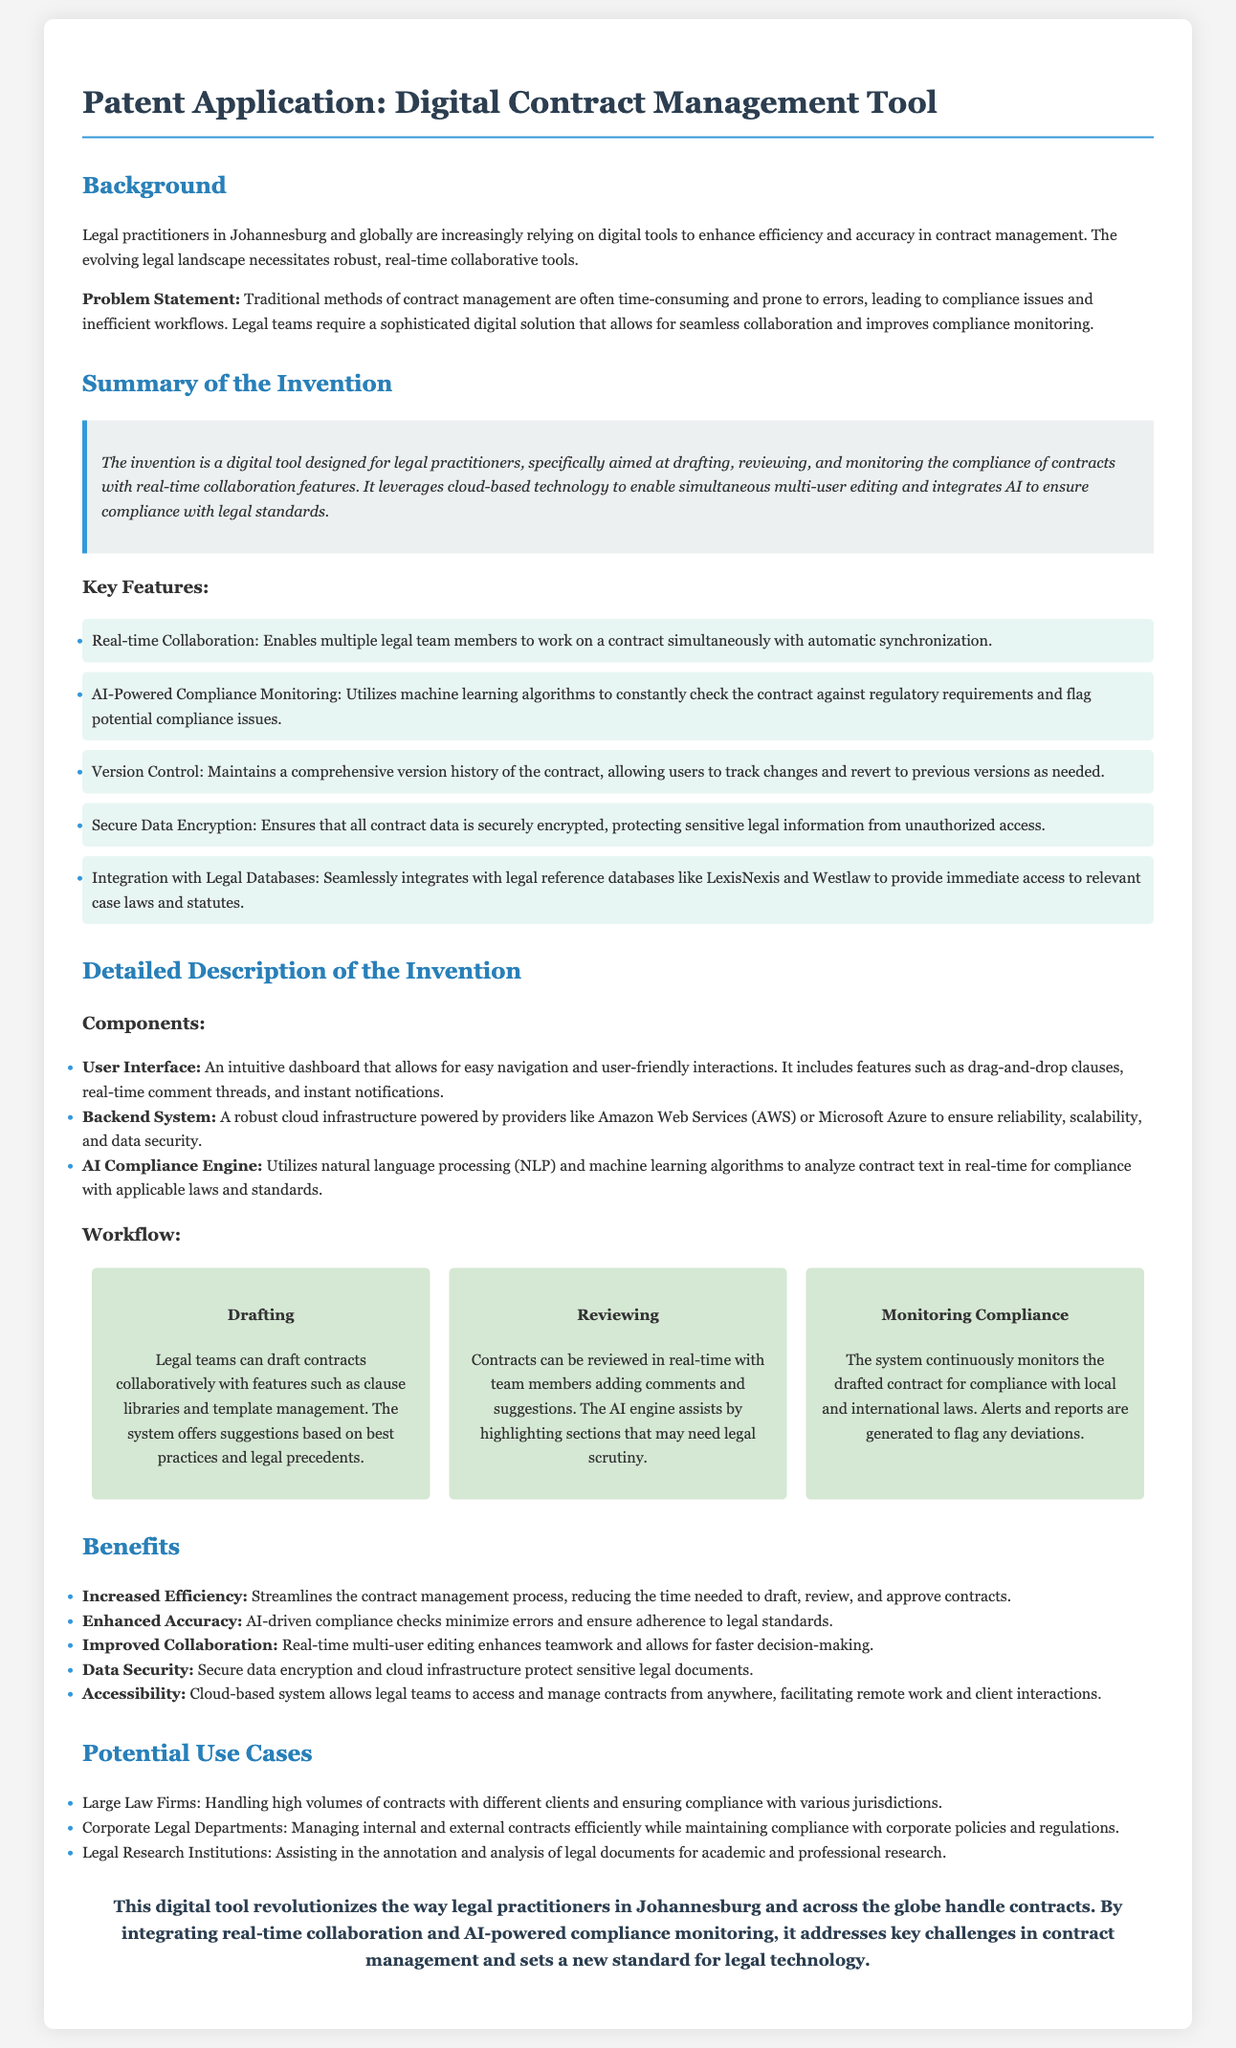What is the title of the patent application? The title of the patent application is clearly stated in the document header.
Answer: Digital Contract Management Tool What is the primary problem addressed by this invention? The document states the problem that traditional methods of contract management are often time-consuming and prone to errors.
Answer: Compliance issues and inefficient workflows What technology does the tool utilize for compliance monitoring? The document mentions a specific technological aspect related to compliance monitoring in the invention.
Answer: AI-Powered Compliance Monitoring What feature ensures secure contract data? The document lists several key features, one of which is directly related to data security.
Answer: Secure Data Encryption In which geographical area is this tool primarily aimed? The background mentions where legal practitioners using this tool are located, which provides context.
Answer: Johannesburg What are the potential use cases mentioned? The document outlines specific contexts in which the tool could be utilized effectively.
Answer: Large Law Firms, Corporate Legal Departments, Legal Research Institutions How many key features are highlighted in the document? The document contains a certain number of features that are essential to the tool, which can be counted.
Answer: Five What does the workflow for the invention consist of? The workflow is described in detail, highlighting sequential steps that legal teams can follow.
Answer: Drafting, Reviewing, Monitoring Compliance Which infrastructure supports the backend system? The document references providers that constitute the cloud infrastructure essential for the tool’s functionality.
Answer: Amazon Web Services (AWS) or Microsoft Azure 